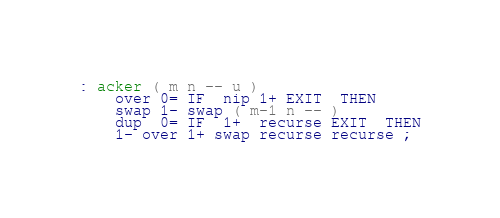Convert code to text. <code><loc_0><loc_0><loc_500><loc_500><_Forth_>: acker ( m n -- u )
	over 0= IF  nip 1+ EXIT  THEN
	swap 1- swap ( m-1 n -- )
	dup  0= IF  1+  recurse EXIT  THEN
	1- over 1+ swap recurse recurse ;
</code> 